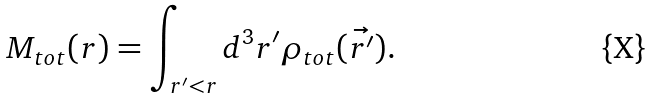<formula> <loc_0><loc_0><loc_500><loc_500>M _ { t o t } ( r ) = \int _ { r ^ { \prime } < r } d ^ { 3 } r ^ { \prime } \rho _ { t o t } ( \vec { r ^ { \prime } } ) .</formula> 